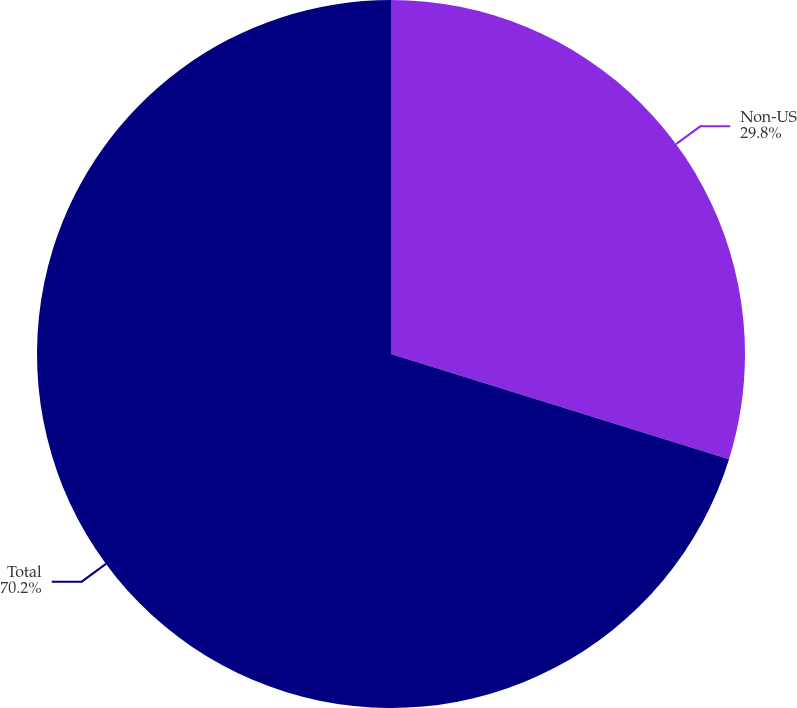Convert chart. <chart><loc_0><loc_0><loc_500><loc_500><pie_chart><fcel>Non-US<fcel>Total<nl><fcel>29.8%<fcel>70.2%<nl></chart> 